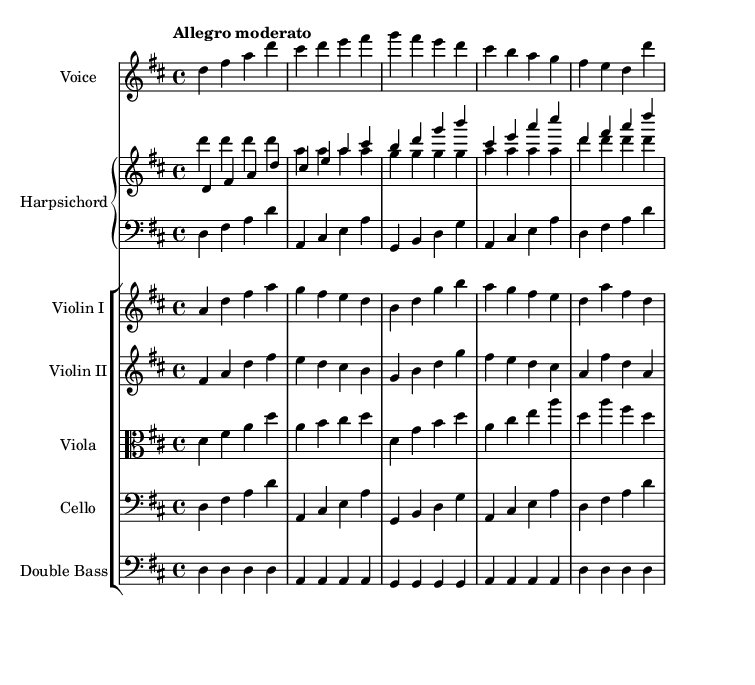What is the key signature of this music? The key signature is indicated at the beginning of the staff and shows two sharps, which correspond to the notes F# and C#. Therefore, the key is D major.
Answer: D major What is the time signature of this music? The time signature is displayed at the beginning of the staff with two numbers, where the top number indicates the number of beats per measure (4), and the bottom number (4) indicates that the quarter note gets one beat. Hence, the time signature is 4/4.
Answer: 4/4 What is the tempo marking given in the score? The tempo marking is usually placed above the staff at the beginning of the piece. It states "Allegro moderato," indicating a moderate pace.
Answer: Allegro moderato How many measures are present in the vocal part? By counting the vertical bar lines that separate the music into measures, we find that the vocal part consists of 5 measures.
Answer: 5 Which instrument has the clef labeled as "alto"? The clef labeled as "alto" signifies that the instrument is meant for playing in the alto range, which corresponds to the viola in this composition.
Answer: Viola What is the role of the harpsichord in this score? The harpsichord is typically designated as the chordal instrument, providing harmonic support. In this score, it has two staves indicating it plays both melody and harmonic parts.
Answer: Harmonic support What thematic idea does the lyric express? The lyrics express a theme of business and expansion with phrases like "Venture forth" and "expanding," indicating entrepreneurial ambition.
Answer: Entrepreneurship 